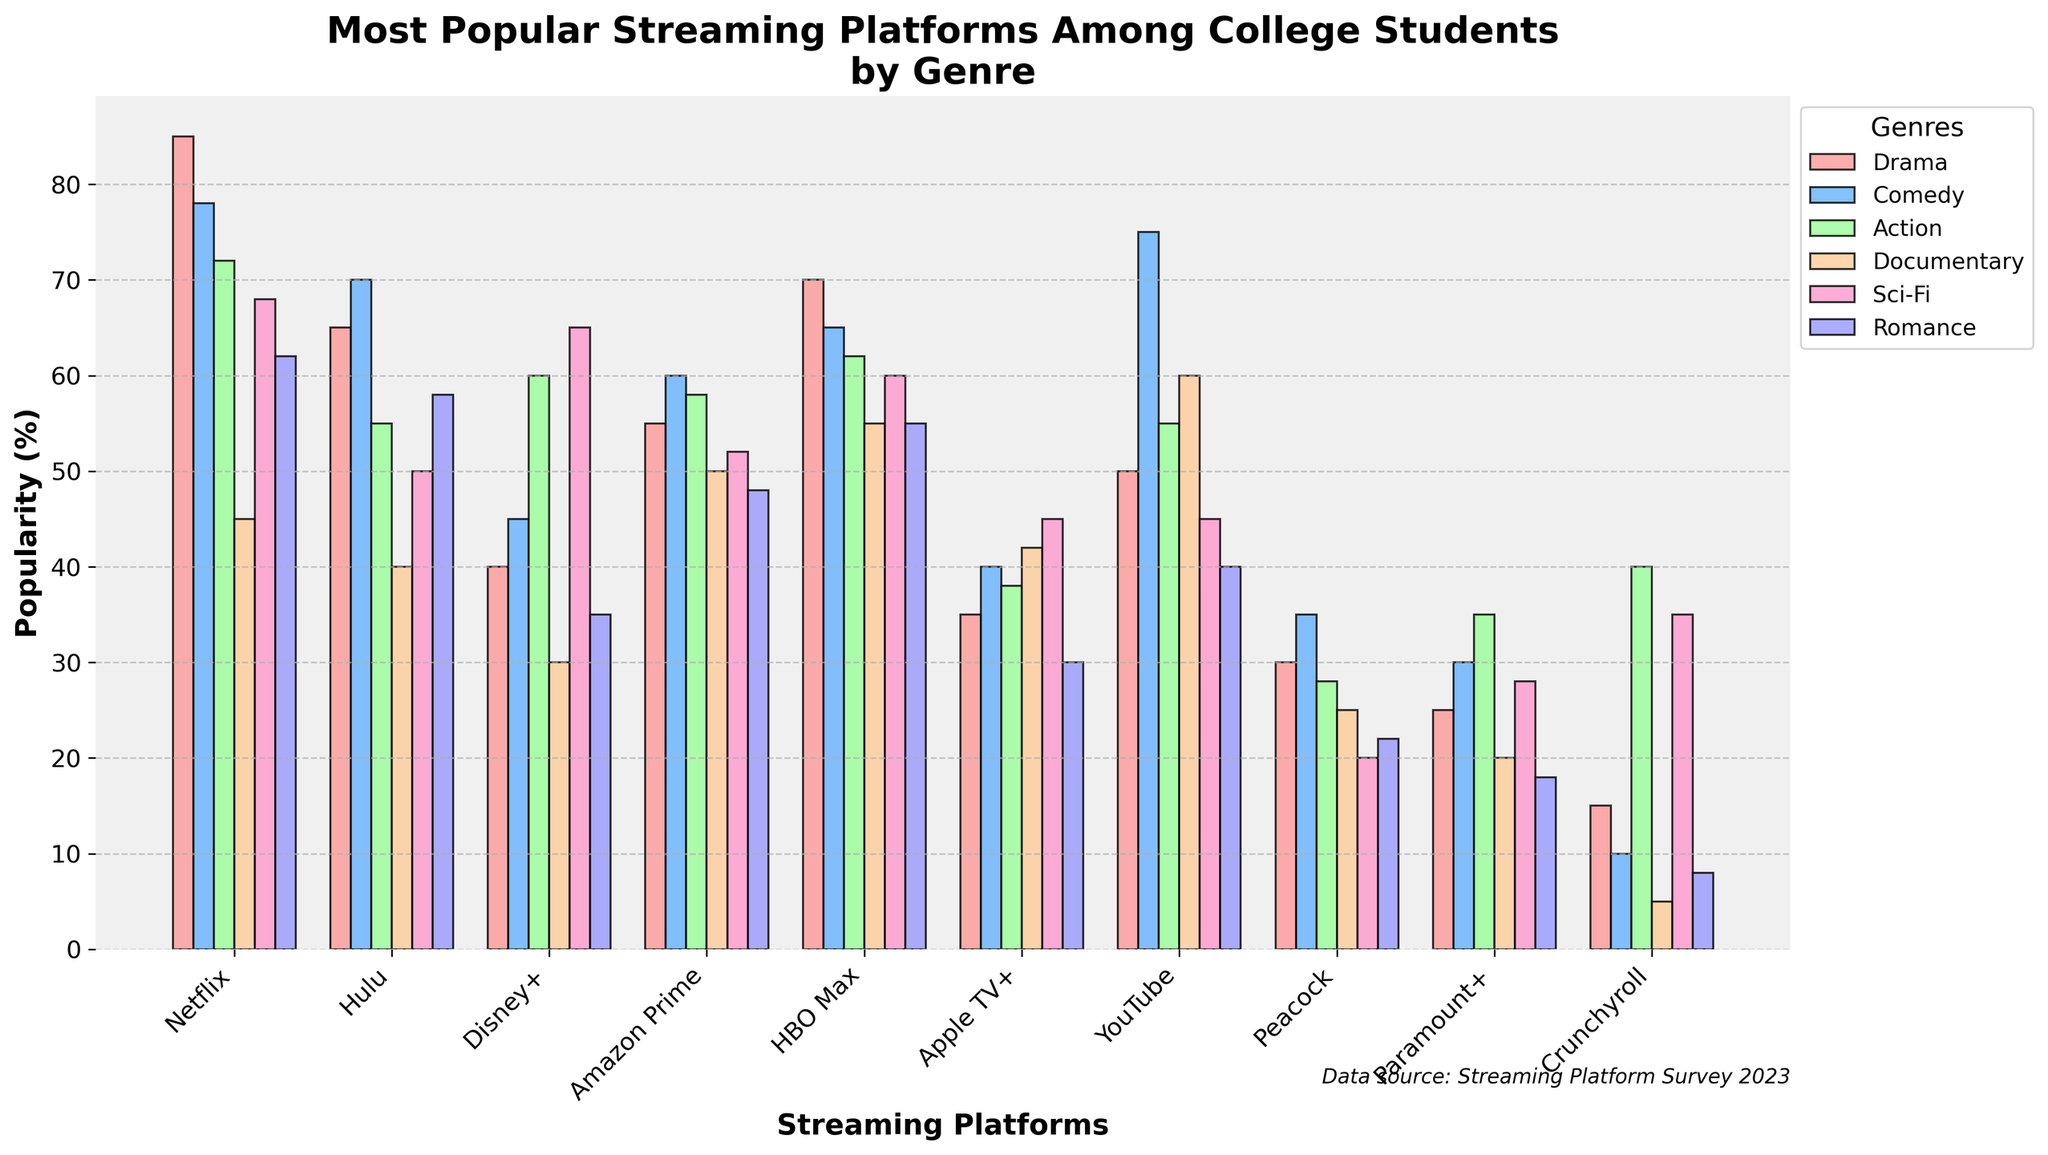Which streaming platform is the most popular for the genre of Drama? Examine the heights of the bars corresponding to Drama for each streaming platform. The tallest bar for Drama represents the most popular platform in this genre, which is Netflix.
Answer: Netflix Which streaming platform is more popular for Comedy, Hulu or Amazon Prime? Compare the heights of the Comedy bars for Hulu and Amazon Prime. Hulu's Comedy bar is taller than Amazon Prime's, indicating that Hulu is more popular for Comedy.
Answer: Hulu How many platforms have a popularity of 60% or more in the Action genre? Identify the bars representing the Action genre and count how many bars are 60% or higher. Hulu, Disney+, Amazon Prime, and HBO Max all have Action genre bars at 60% or higher.
Answer: 4 What is the difference in popularity for Sci-Fi between Disney+ and Crunchyroll? Find the Sci-Fi bars for Disney+ and Crunchyroll and subtract the height of Crunchyroll's Sci-Fi bar from Disney+'s. Disney+ has a Sci-Fi popularity of 65%, while Crunchyroll has 35%, making the difference 30%.
Answer: 30% Which genre is the least popular on Peacock? Compare all the genre bars for Peacock and find the shortest one. The Documentary genre bar is the shortest for Peacock at 25%.
Answer: Documentary What is the average popularity percentage for Documentary across all platforms? Add the Documentary values for all platforms and divide by the number of platforms. (45 + 40 + 30 + 50 + 55 + 42 + 60 + 25 + 20 + 5) / 10 = 37.2%
Answer: 37.2% If you sum the popularity of Drama and Romance for Netflix, how does it compare to the sum for Hulu? Add Drama and Romance values for both Netflix and Hulu then compare. Netflix: 85 + 62 = 147, Hulu: 65 + 58 = 123. Netflix's sum is greater.
Answer: Netflix Is YouTube more popular for Documentaries or Romances? Compare the bars for Documentaries and Romances for YouTube. The Documentary bar is taller than the Romance bar, indicating YouTube is more popular for Documentaries.
Answer: Documentaries Which platform has the highest popularity in Action, and what is that percentage? Find the Action genre bar that is the tallest across all platforms. HBO Max has the highest popularity in Action at 62%.
Answer: HBO Max, 62% Between Netflix and HBO Max, which has a higher average popularity across all genres? Calculate the average popularity for Netflix and HBO Max then compare. Netflix: (85 + 78 + 72 + 45 + 68 + 62) / 6 = 68.33%. HBO Max: (70 + 65 + 62 + 55 + 60 + 55) / 6 = 61.17%. Netflix has a higher average.
Answer: Netflix 